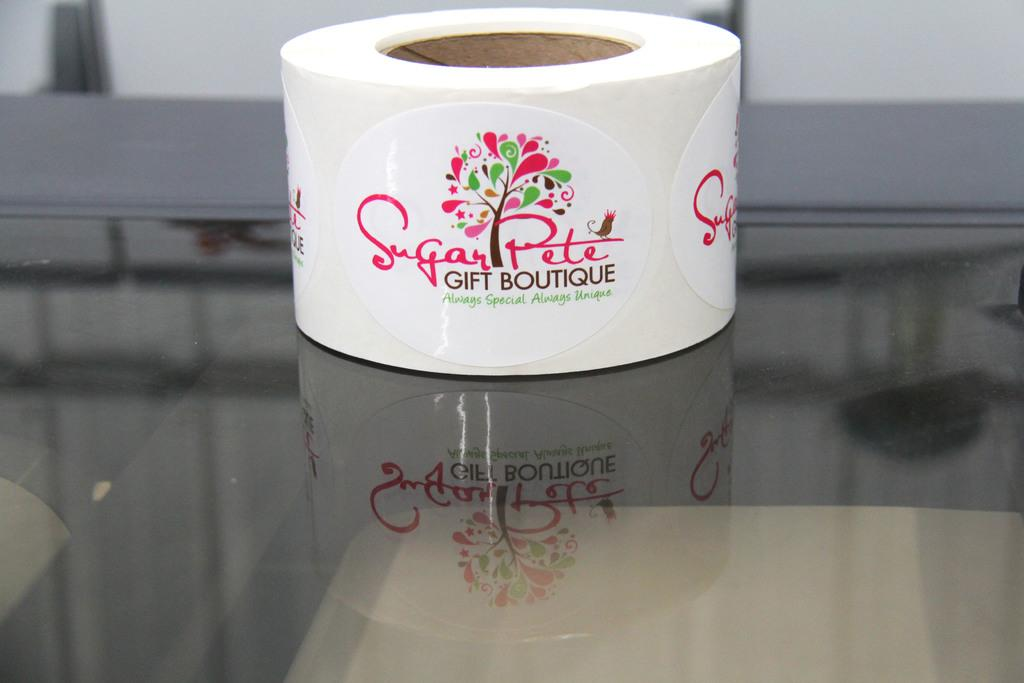What is present in the image that has labels on it? There is a tape in the image that has labels on it. What is the tape placed on in the image? The tape is on a transparent glass object. Can you describe the background of the image? The background of the image is blurred. What type of engine can be seen in the image? There is no engine present in the image. How many oranges are visible in the image? There are no oranges present in the image. 